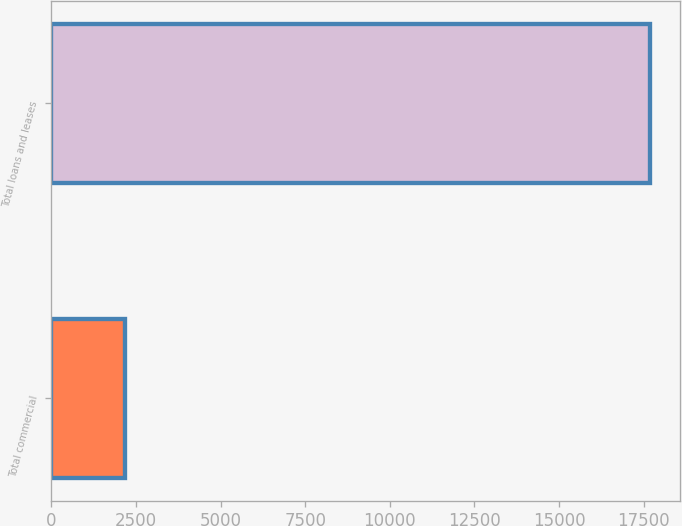Convert chart. <chart><loc_0><loc_0><loc_500><loc_500><bar_chart><fcel>Total commercial<fcel>Total loans and leases<nl><fcel>2172<fcel>17685<nl></chart> 